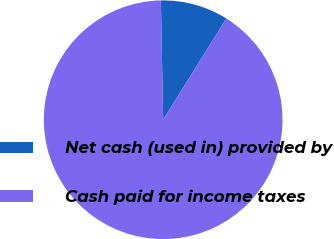<chart> <loc_0><loc_0><loc_500><loc_500><pie_chart><fcel>Net cash (used in) provided by<fcel>Cash paid for income taxes<nl><fcel>9.19%<fcel>90.81%<nl></chart> 